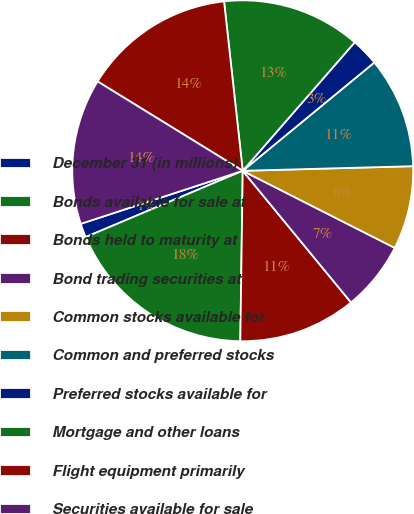Convert chart to OTSL. <chart><loc_0><loc_0><loc_500><loc_500><pie_chart><fcel>December 31 (in millions)<fcel>Bonds available for sale at<fcel>Bonds held to maturity at<fcel>Bond trading securities at<fcel>Common stocks available for<fcel>Common and preferred stocks<fcel>Preferred stocks available for<fcel>Mortgage and other loans<fcel>Flight equipment primarily<fcel>Securities available for sale<nl><fcel>1.32%<fcel>18.42%<fcel>11.18%<fcel>6.58%<fcel>7.9%<fcel>10.53%<fcel>2.63%<fcel>13.16%<fcel>14.47%<fcel>13.82%<nl></chart> 